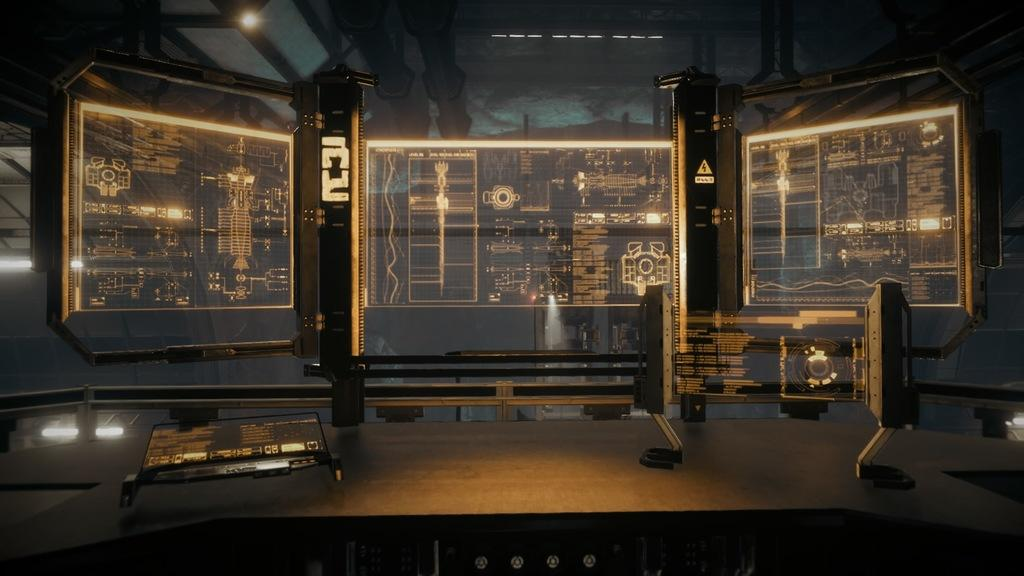What type of image is being described? The image is animated. What objects can be seen in the animated image? There are screens visible in the image. What type of insect can be seen crawling on the screens in the image? There are no insects visible in the image; it only features screens. 